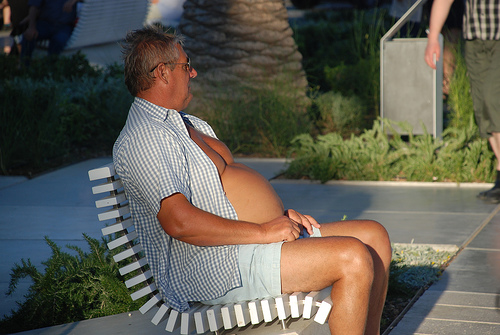<image>
Can you confirm if the sleeve is above the slat? No. The sleeve is not positioned above the slat. The vertical arrangement shows a different relationship. 